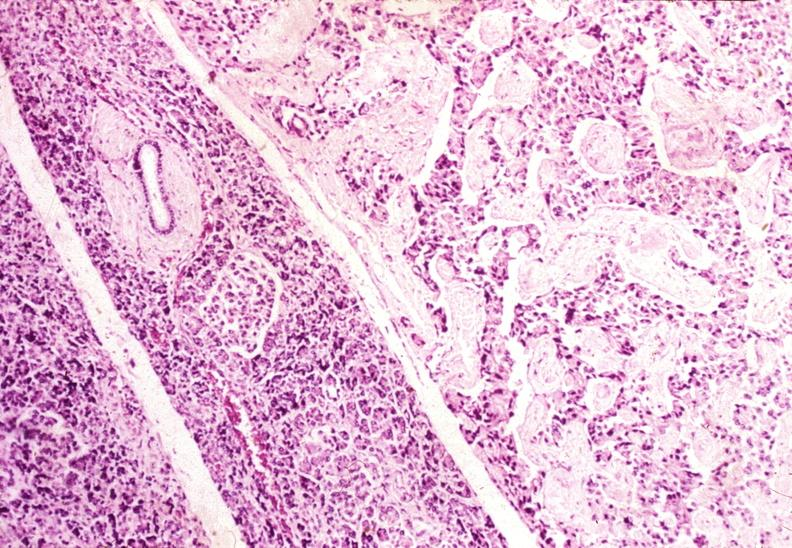what is present?
Answer the question using a single word or phrase. Pancreas 